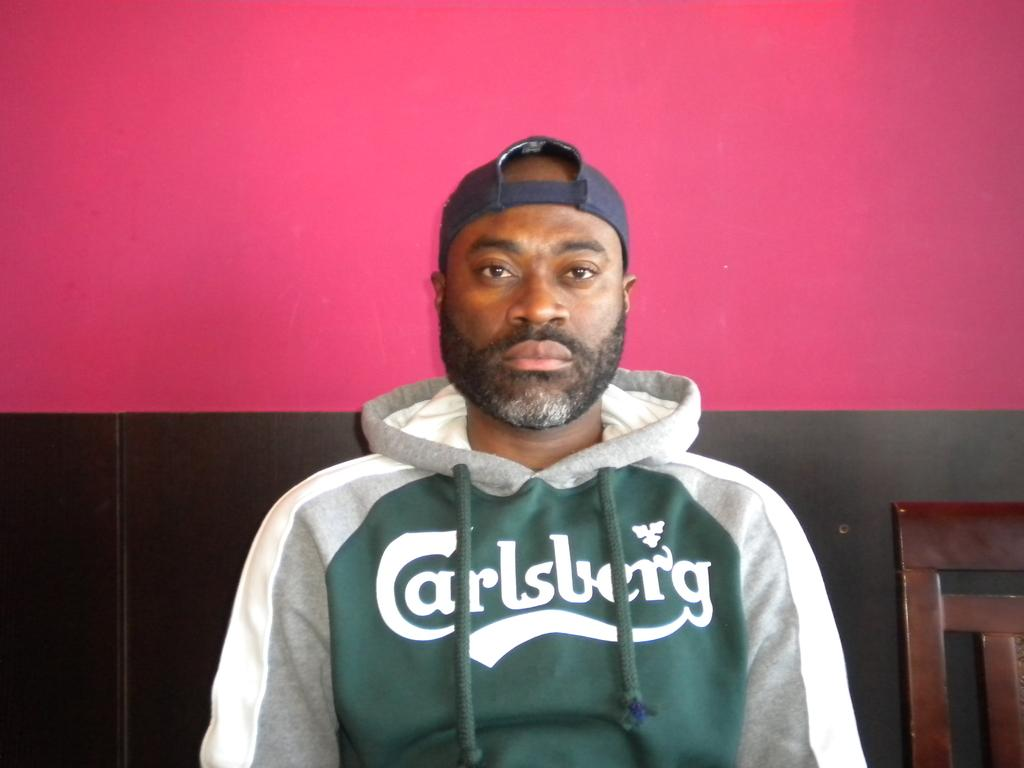<image>
Give a short and clear explanation of the subsequent image. A man wears a hoodie that says carlsburg. 